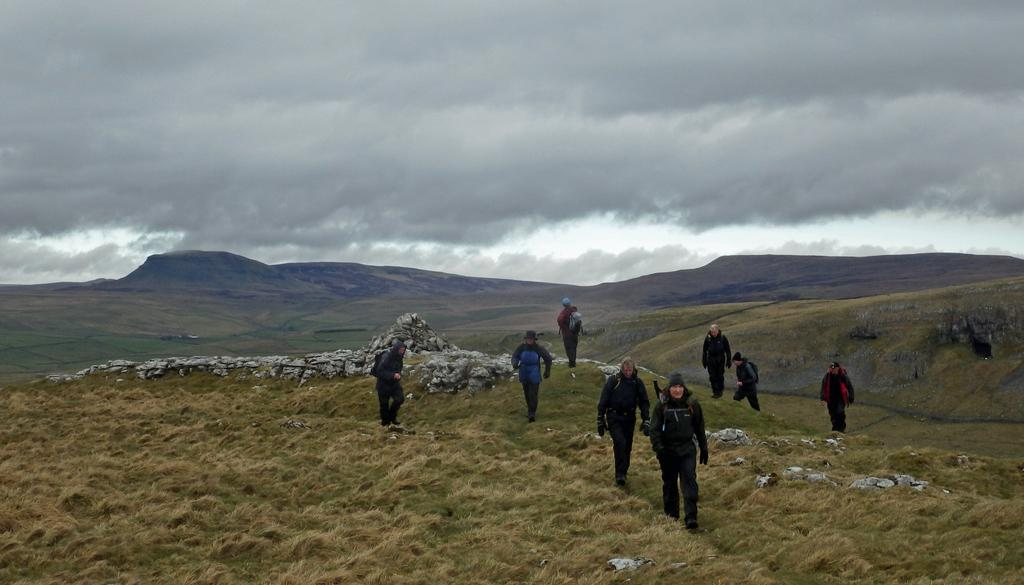What are the persons in the image doing? The persons in the image are walking. On what surface are the persons walking? The persons are walking on the ground. What can be seen in the background of the image? There are hills and the sky visible in the background of the image. What is the condition of the sky in the image? The sky is visible with clouds in the background of the image. What type of natural feature can be seen in the background of the image? Stones are present in the background of the image. What page of the book are the persons reading while walking in the image? There is no book or reading activity depicted in the image; the persons are simply walking. How does the zebra feel about the persons walking in the image? There is no zebra present in the image, so it is not possible to determine how it might feel about the persons walking. 